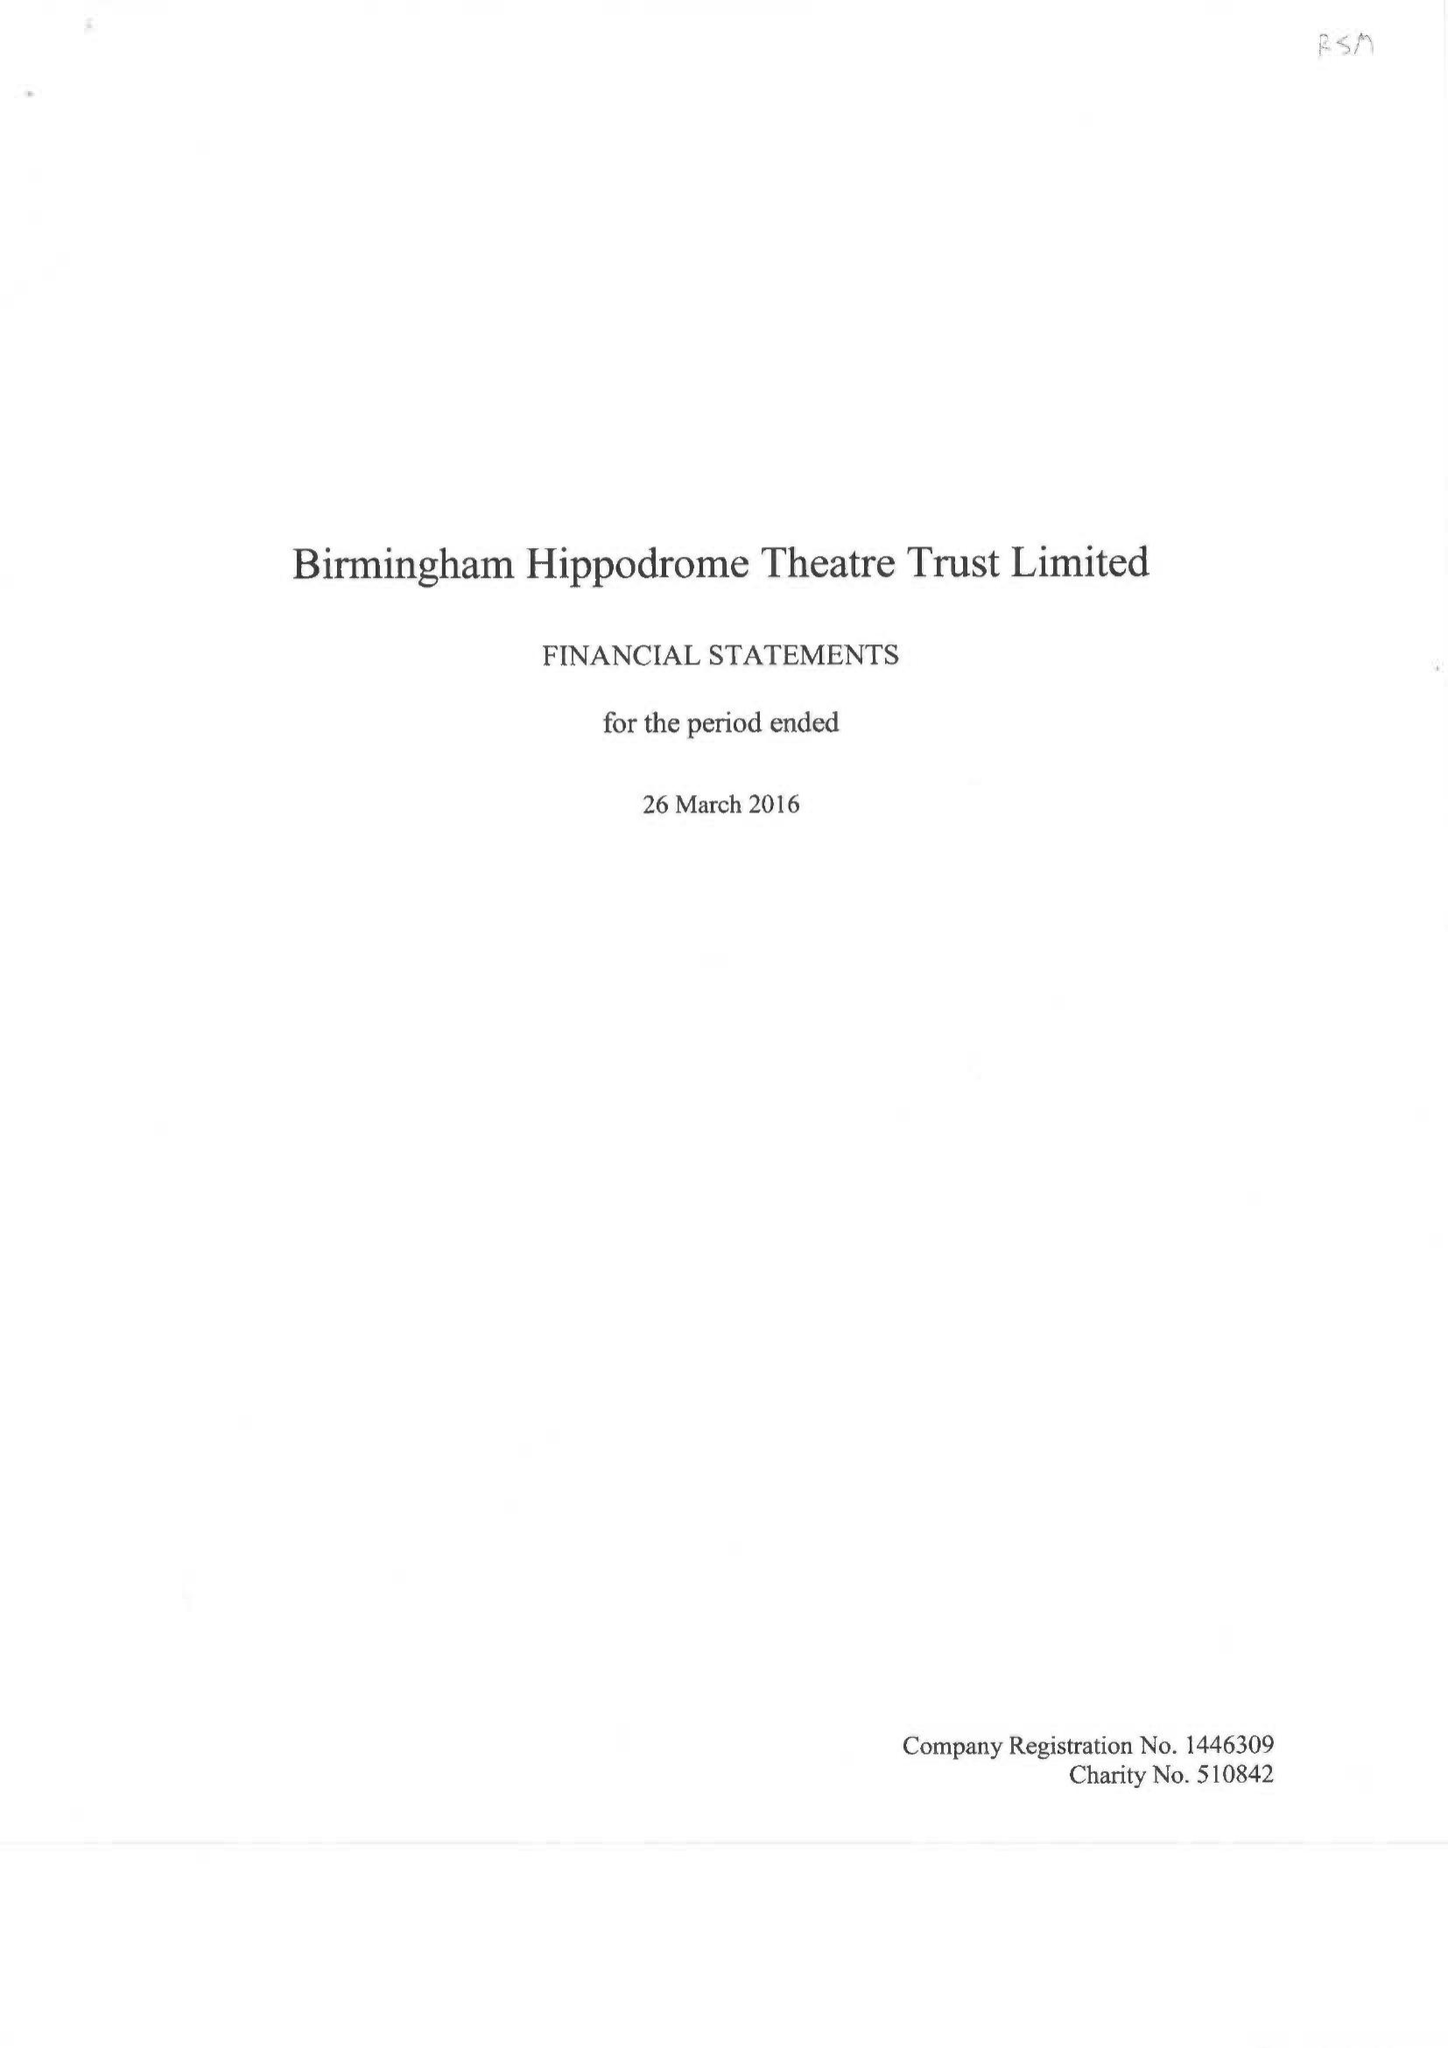What is the value for the spending_annually_in_british_pounds?
Answer the question using a single word or phrase. 25118000.00 